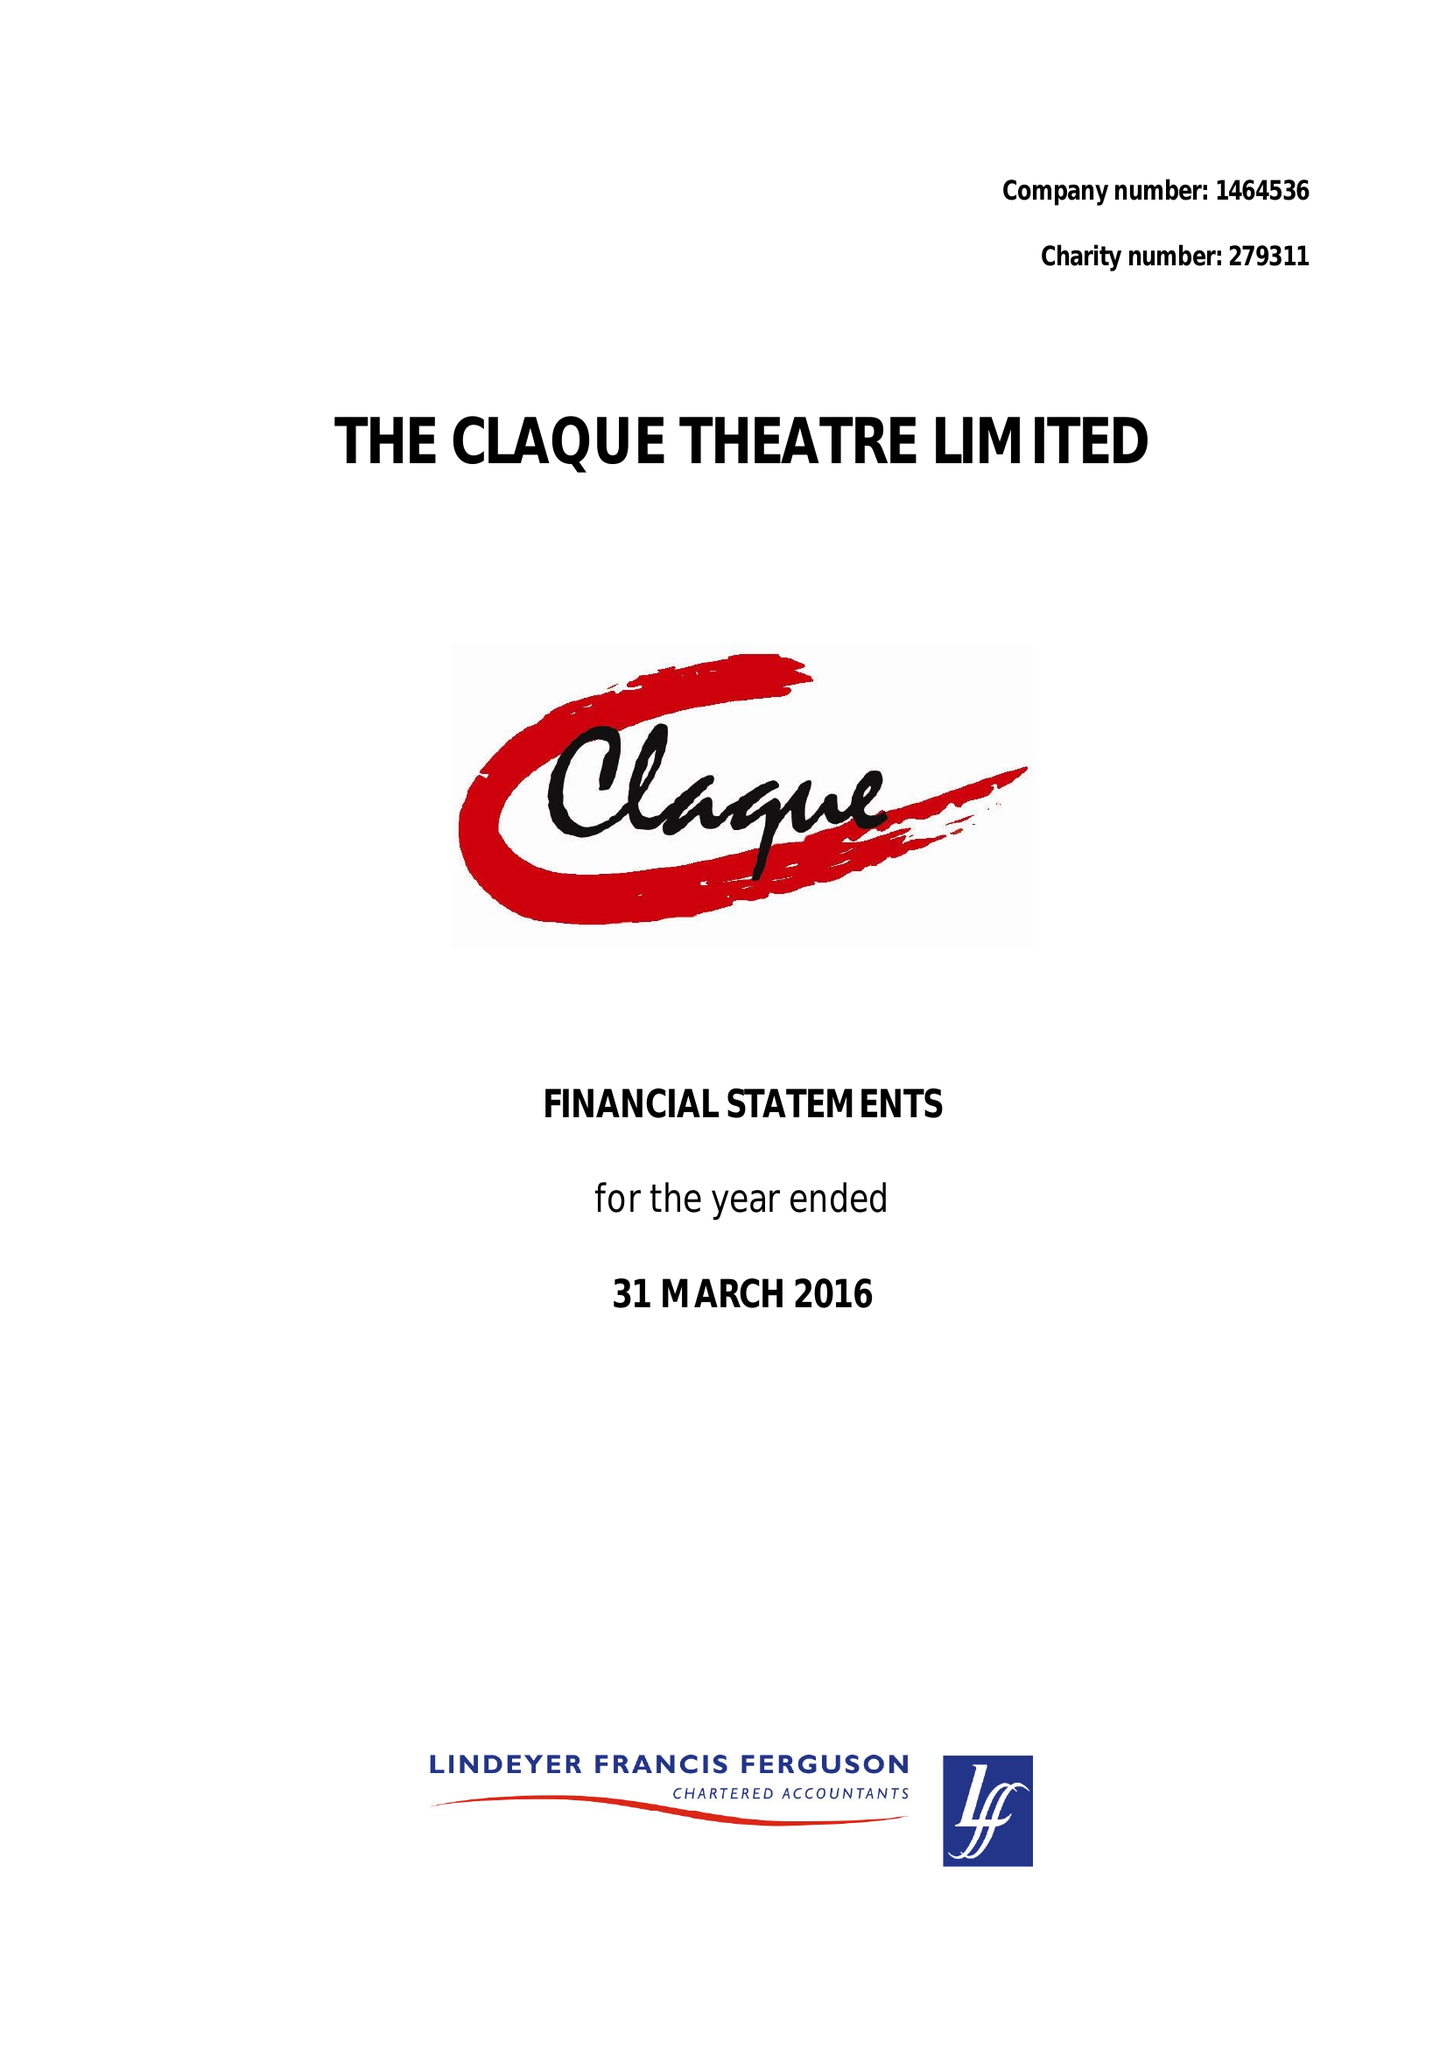What is the value for the charity_number?
Answer the question using a single word or phrase. 279311 